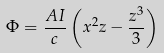Convert formula to latex. <formula><loc_0><loc_0><loc_500><loc_500>\Phi = \frac { A I } { c } \left ( x ^ { 2 } z - \frac { z ^ { 3 } } { 3 } \right )</formula> 